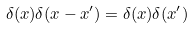Convert formula to latex. <formula><loc_0><loc_0><loc_500><loc_500>\delta ( x ) \delta ( x - x ^ { \prime } ) = \delta ( x ) \delta ( x ^ { \prime } )</formula> 